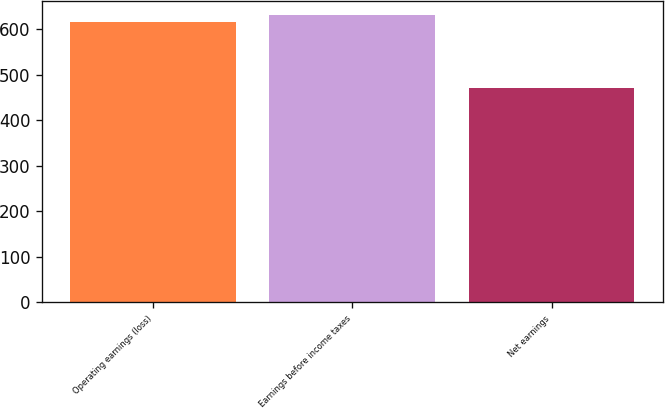Convert chart. <chart><loc_0><loc_0><loc_500><loc_500><bar_chart><fcel>Operating earnings (loss)<fcel>Earnings before income taxes<fcel>Net earnings<nl><fcel>615.8<fcel>631.35<fcel>470.4<nl></chart> 